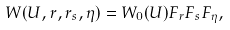Convert formula to latex. <formula><loc_0><loc_0><loc_500><loc_500>W ( U , r , r _ { s } , \eta ) = W _ { 0 } ( U ) F _ { r } F _ { s } F _ { \eta } ,</formula> 